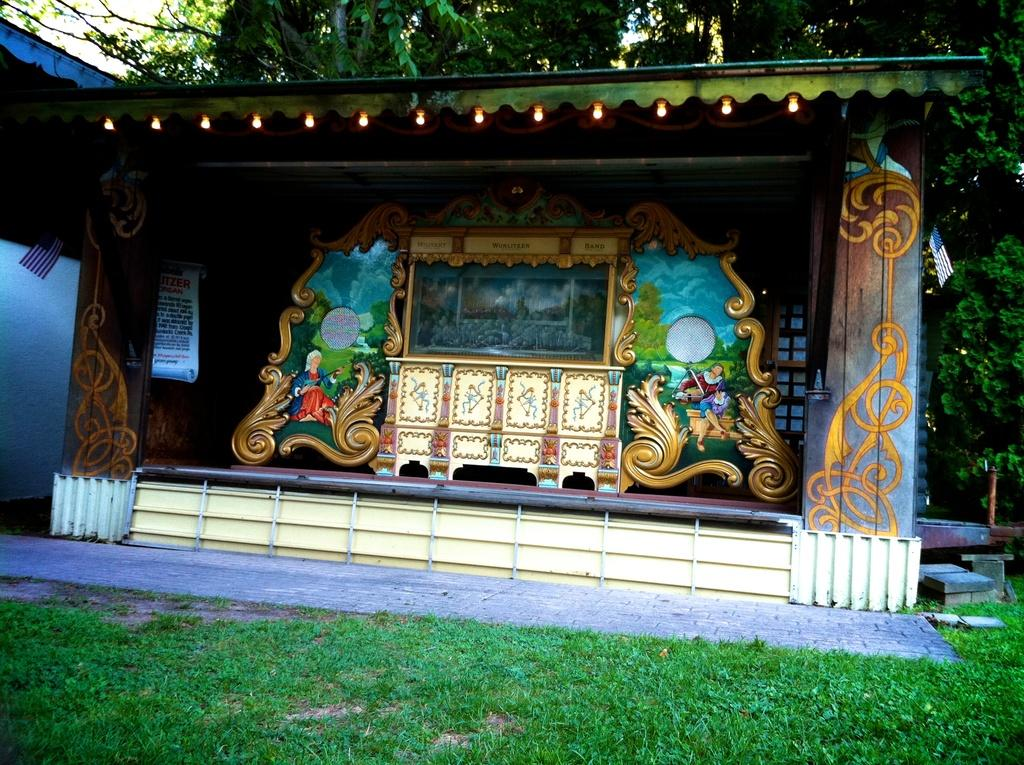What type of vegetation can be seen in the image? There is grass in the image. What structures are present in the image? There is a shed and a house in the image. What additional objects can be seen in the image? There is a board, lights, metal rods, photo frames, and a stand in the image. What natural elements are visible in the image? There are trees and the sky is visible in the image. Can you describe the time of day the image may have been taken? The image may have been taken in the evening, as indicated by the presence of lights. Can you see any windows in the image? There is no mention of a window in the provided facts, so we cannot determine if there is a window present in the image. Are there any waves visible in the image? There is no reference to water or waves in the image, so we cannot determine if there are any waves present. What type of animal can be seen in the image? There is no mention of an animal in the provided facts, so we cannot determine if there is an animal present in the image. 